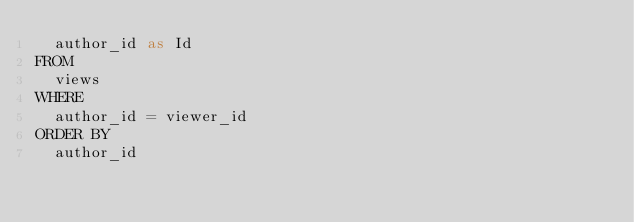Convert code to text. <code><loc_0><loc_0><loc_500><loc_500><_SQL_>  author_id as Id
FROM
  views
WHERE
  author_id = viewer_id
ORDER BY
  author_id</code> 